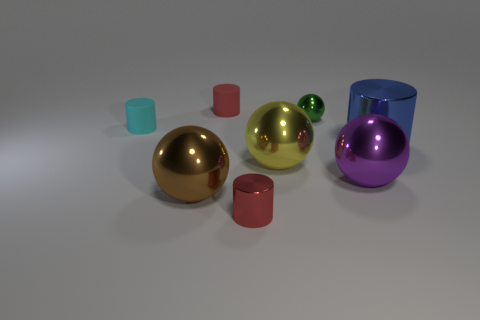Are there any small things of the same color as the tiny metallic cylinder?
Make the answer very short. Yes. There is a small matte object that is on the right side of the big brown metal sphere; is it the same color as the small shiny cylinder?
Keep it short and to the point. Yes. What number of objects are metal things in front of the small shiny ball or small metal balls?
Give a very brief answer. 6. There is a green object; are there any cyan things to the left of it?
Your answer should be very brief. Yes. There is a tiny object that is the same color as the small shiny cylinder; what is its material?
Offer a terse response. Rubber. Does the tiny cylinder in front of the large blue metallic cylinder have the same material as the purple ball?
Your answer should be compact. Yes. Are there any red cylinders that are to the left of the small shiny thing that is in front of the big metallic sphere that is left of the large yellow metallic object?
Offer a terse response. Yes. What number of cylinders are either big gray shiny objects or big metallic objects?
Offer a very short reply. 1. There is a cylinder that is behind the green ball; what is its material?
Your response must be concise. Rubber. There is another cylinder that is the same color as the tiny shiny cylinder; what is its size?
Offer a very short reply. Small. 